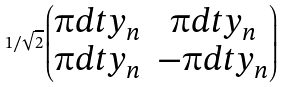Convert formula to latex. <formula><loc_0><loc_0><loc_500><loc_500>1 / \sqrt { 2 } \begin{pmatrix} \i d t y _ { n } & \i d t y _ { n } \\ \i d t y _ { n } & - \i d t y _ { n } \end{pmatrix}</formula> 